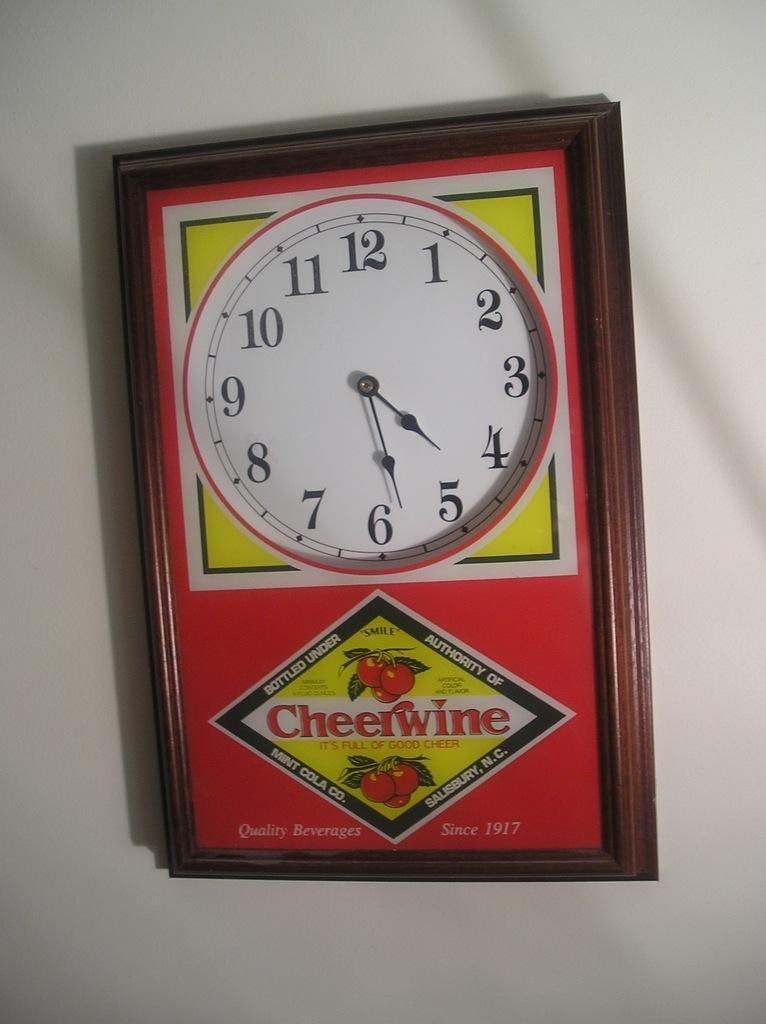<image>
Describe the image concisely. Red clock which says Cheerwine on it in the front. 